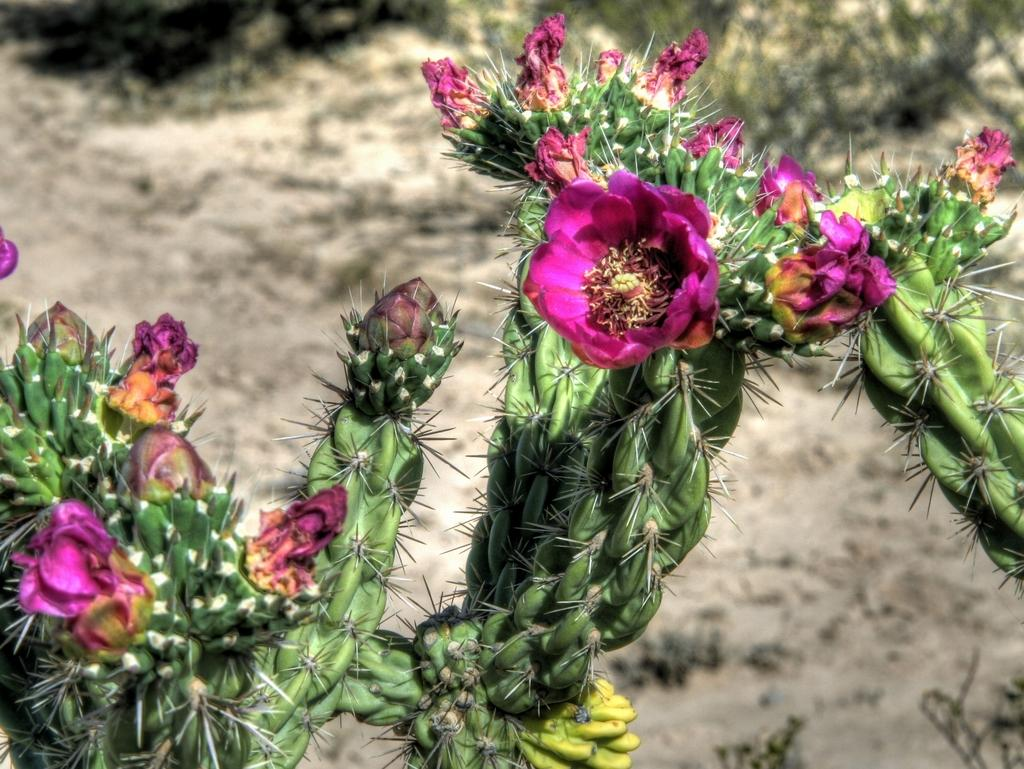What type of plants are in the image? There are cactus plants in the image. What additional feature can be observed on the cactus plants? The cactus plants have flowers. Can you describe the background of the image? The background of the image is blurred. Is there a squirrel climbing the cactus plants in the image? No, there is no squirrel present in the image. What type of drain can be seen in the image? There is no drain present in the image; it features cactus plants with flowers and a blurred background. 